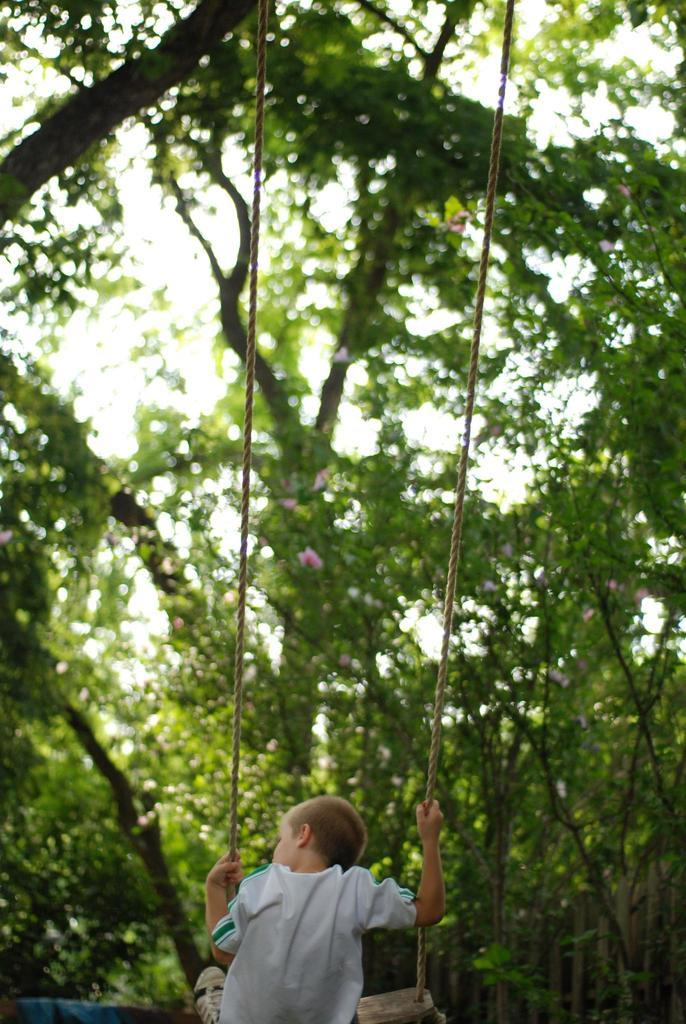What is the main subject of the image? There is a boy in the image. What is the boy doing in the image? The boy is on a swing. What is the boy wearing in the image? The boy is wearing a white T-shirt and shoes. What can be seen in the background of the image? There are trees and the sky visible in the background of the image. What type of hen can be seen in the image? There is no hen present in the image. What account does the boy have with the swing manufacturer? There is no information about any account in the image. 